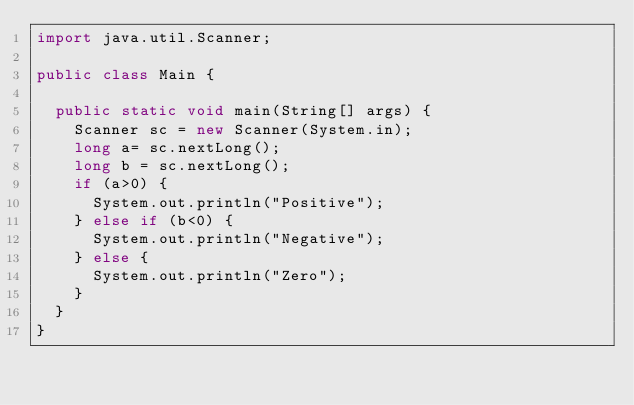<code> <loc_0><loc_0><loc_500><loc_500><_Java_>import java.util.Scanner;

public class Main {

	public static void main(String[] args) {
		Scanner sc = new Scanner(System.in);
		long a= sc.nextLong();
		long b = sc.nextLong();
		if (a>0) {
			System.out.println("Positive");
		} else if (b<0) {
			System.out.println("Negative");
		} else {
			System.out.println("Zero");
		}
	}
}</code> 